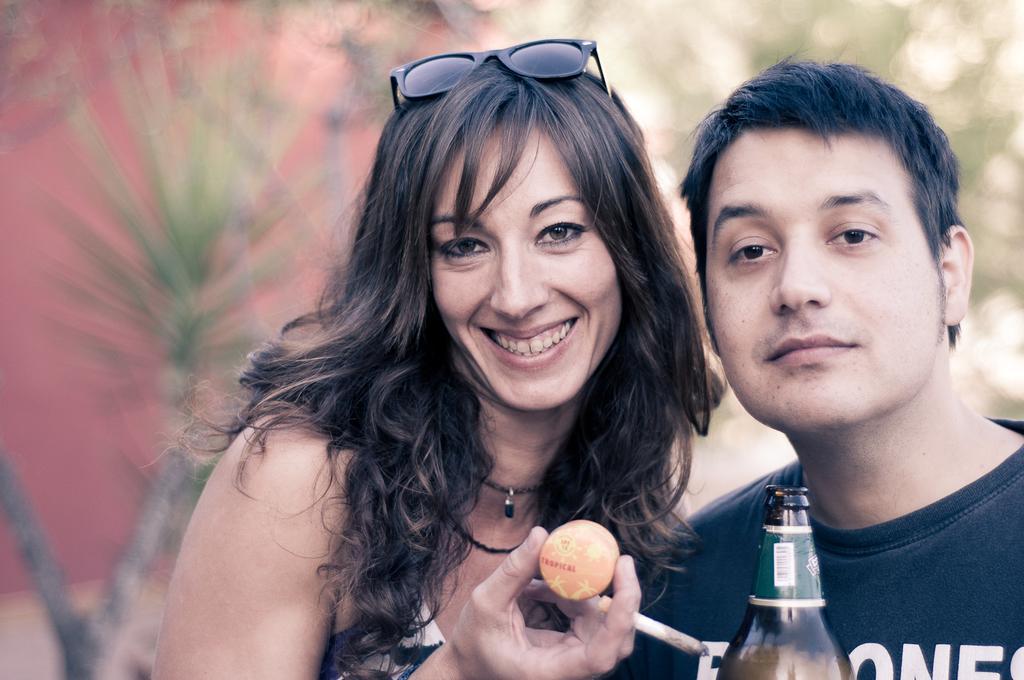Can you describe this image briefly? In this image we can see one bottle, two persons, one woman is holding a cigarette and one ball. Backside of these two persons one pink wall and some trees are there. 